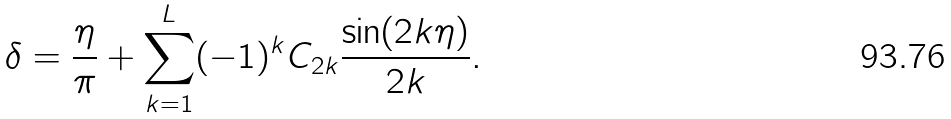Convert formula to latex. <formula><loc_0><loc_0><loc_500><loc_500>\delta = \frac { \eta } { \pi } + \sum _ { k = 1 } ^ { L } ( - 1 ) ^ { k } C _ { 2 k } \frac { \sin ( 2 k \eta ) } { 2 k } .</formula> 